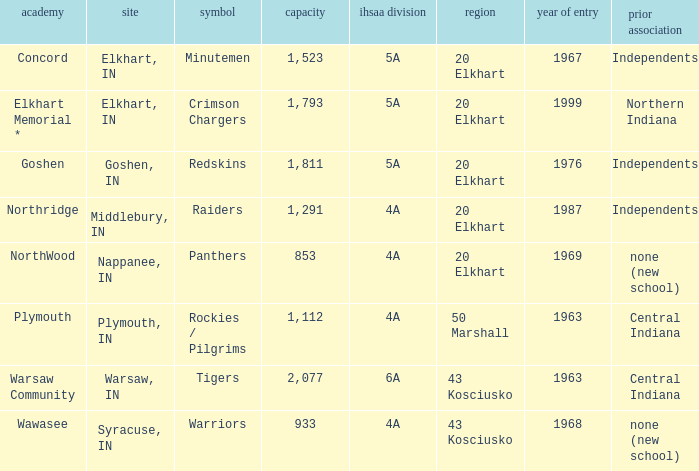What is the size of the team that was previously from Central Indiana conference, and is in IHSSA Class 4a? 1112.0. 